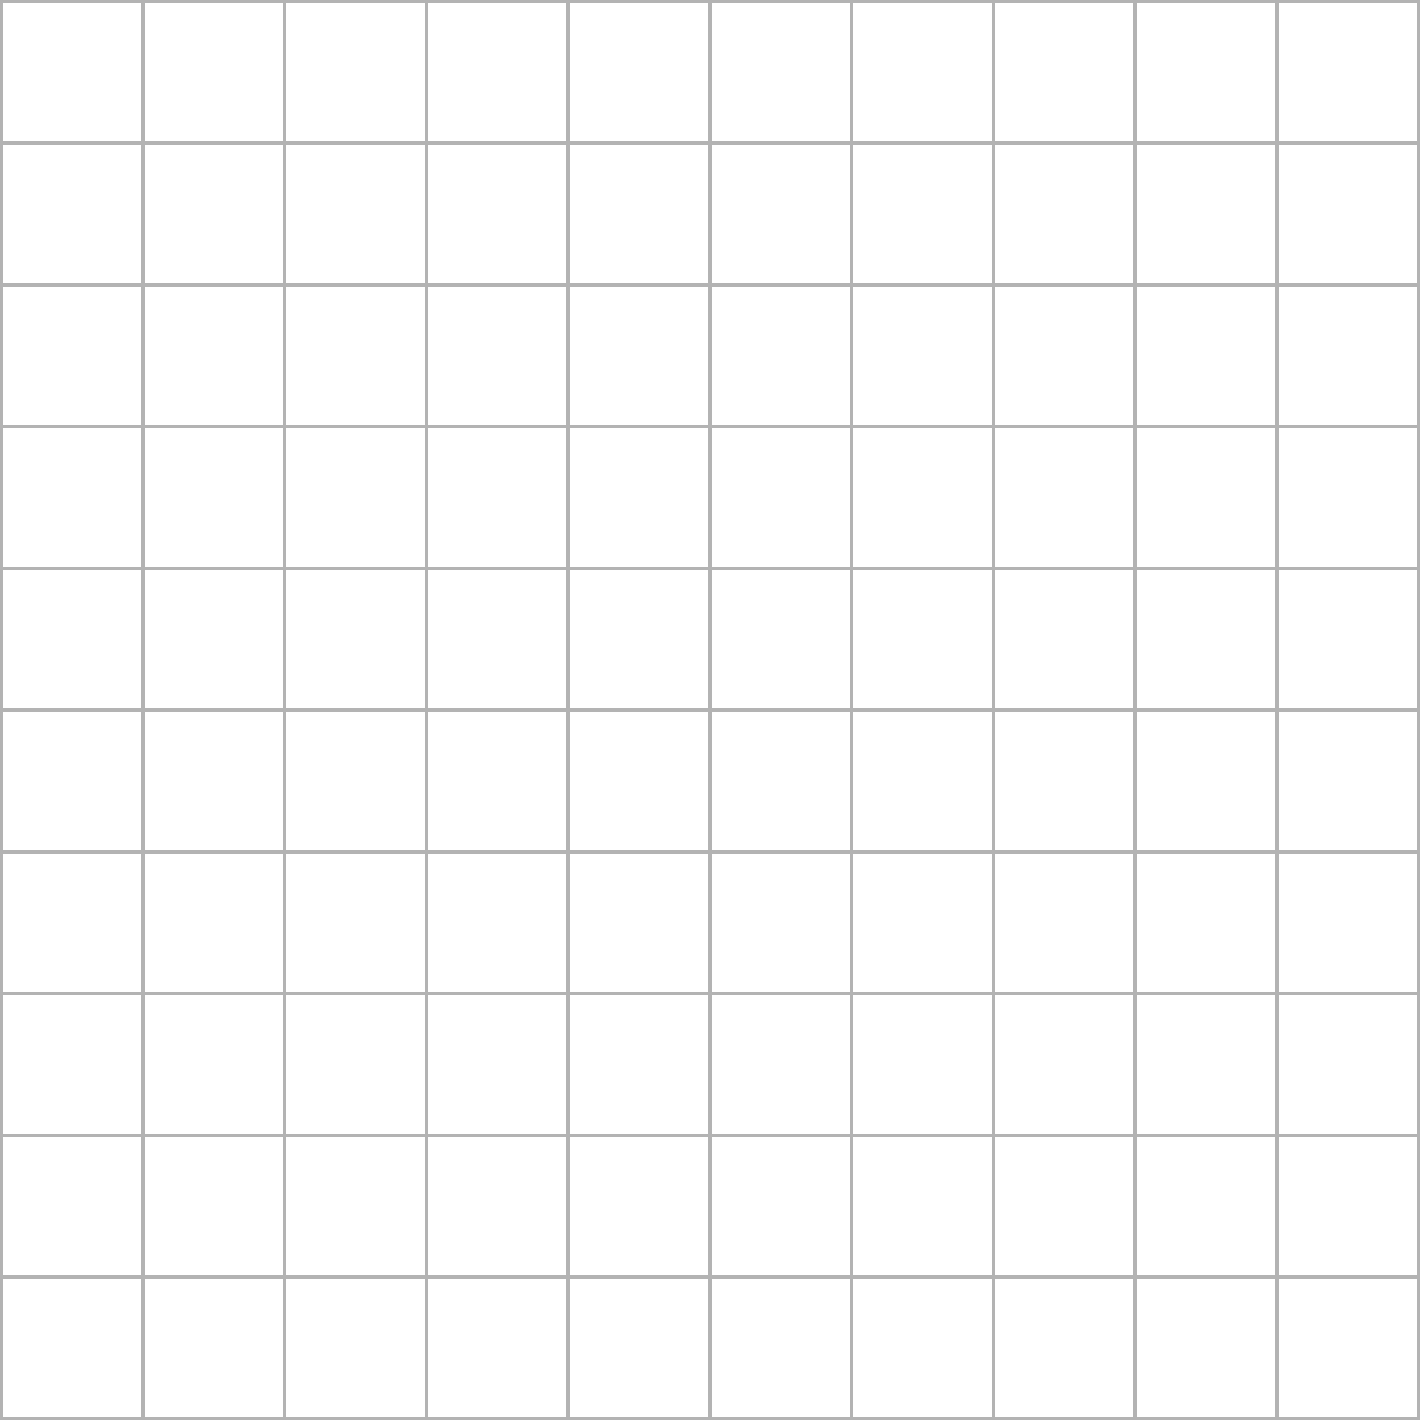In the Game of Thrones universe, you're tasked with determining the area of Winterfell's courtyard for strategic defense planning. The courtyard is represented by the polygon ABCDEF on a grid where each square has an area of 1 square unit. Calculate the area of Winterfell's courtyard. To find the area of Winterfell's courtyard, we'll use the shoelace formula (also known as the surveyor's formula) for calculating the area of a polygon given its vertices. Let's follow these steps:

1) First, let's identify the coordinates of the vertices:
   A(2,2), B(8,2), C(8,6), D(6,8), E(4,8), F(2,6)

2) The shoelace formula for a polygon with n vertices $(x_1,y_1), (x_2,y_2), ..., (x_n,y_n)$ is:

   $$Area = \frac{1}{2}|(x_1y_2 + x_2y_3 + ... + x_ny_1) - (y_1x_2 + y_2x_3 + ... + y_nx_1)|$$

3) Let's apply this formula to our polygon:

   $$\begin{align*}
   Area &= \frac{1}{2}|[(2\cdot2 + 8\cdot6 + 8\cdot8 + 6\cdot8 + 4\cdot6 + 2\cdot2) \\
   &\quad - (2\cdot8 + 2\cdot8 + 6\cdot6 + 8\cdot4 + 8\cdot2 + 6\cdot2)]| \\
   &= \frac{1}{2}|(4 + 48 + 64 + 48 + 24 + 4) - (16 + 16 + 36 + 32 + 16 + 12)| \\
   &= \frac{1}{2}|192 - 128| \\
   &= \frac{1}{2} \cdot 64 \\
   &= 32
   \end{align*}$$

4) Therefore, the area of Winterfell's courtyard is 32 square units.

This calculation method is similar to planning troop movements in strategy games, where understanding the layout and size of an area is crucial for tactical decisions.
Answer: 32 square units 